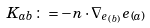<formula> <loc_0><loc_0><loc_500><loc_500>K _ { a b } \colon = - n \cdot \nabla _ { e _ { ( b ) } } e _ { ( a ) }</formula> 